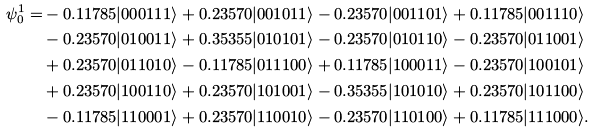<formula> <loc_0><loc_0><loc_500><loc_500>\psi _ { 0 } ^ { 1 } = & - 0 . 1 1 7 8 5 | 0 0 0 1 1 1 \rangle + 0 . 2 3 5 7 0 | 0 0 1 0 1 1 \rangle - 0 . 2 3 5 7 0 | 0 0 1 1 0 1 \rangle + 0 . 1 1 7 8 5 | 0 0 1 1 1 0 \rangle \\ & - 0 . 2 3 5 7 0 | 0 1 0 0 1 1 \rangle + 0 . 3 5 3 5 5 | 0 1 0 1 0 1 \rangle - 0 . 2 3 5 7 0 | 0 1 0 1 1 0 \rangle - 0 . 2 3 5 7 0 | 0 1 1 0 0 1 \rangle \\ & + 0 . 2 3 5 7 0 | 0 1 1 0 1 0 \rangle - 0 . 1 1 7 8 5 | 0 1 1 1 0 0 \rangle + 0 . 1 1 7 8 5 | 1 0 0 0 1 1 \rangle - 0 . 2 3 5 7 0 | 1 0 0 1 0 1 \rangle \\ & + 0 . 2 3 5 7 0 | 1 0 0 1 1 0 \rangle + 0 . 2 3 5 7 0 | 1 0 1 0 0 1 \rangle - 0 . 3 5 3 5 5 | 1 0 1 0 1 0 \rangle + 0 . 2 3 5 7 0 | 1 0 1 1 0 0 \rangle \\ & - 0 . 1 1 7 8 5 | 1 1 0 0 0 1 \rangle + 0 . 2 3 5 7 0 | 1 1 0 0 1 0 \rangle - 0 . 2 3 5 7 0 | 1 1 0 1 0 0 \rangle + 0 . 1 1 7 8 5 | 1 1 1 0 0 0 \rangle .</formula> 